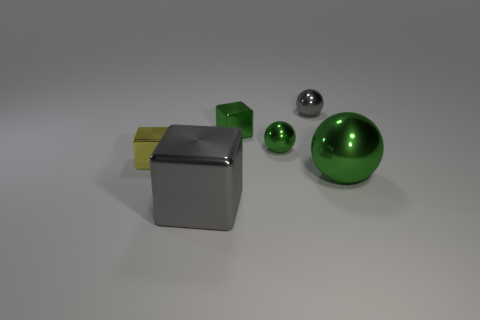Add 2 brown metal blocks. How many objects exist? 8 Subtract 0 cyan balls. How many objects are left? 6 Subtract all small red spheres. Subtract all small yellow metal cubes. How many objects are left? 5 Add 2 tiny objects. How many tiny objects are left? 6 Add 5 big gray cubes. How many big gray cubes exist? 6 